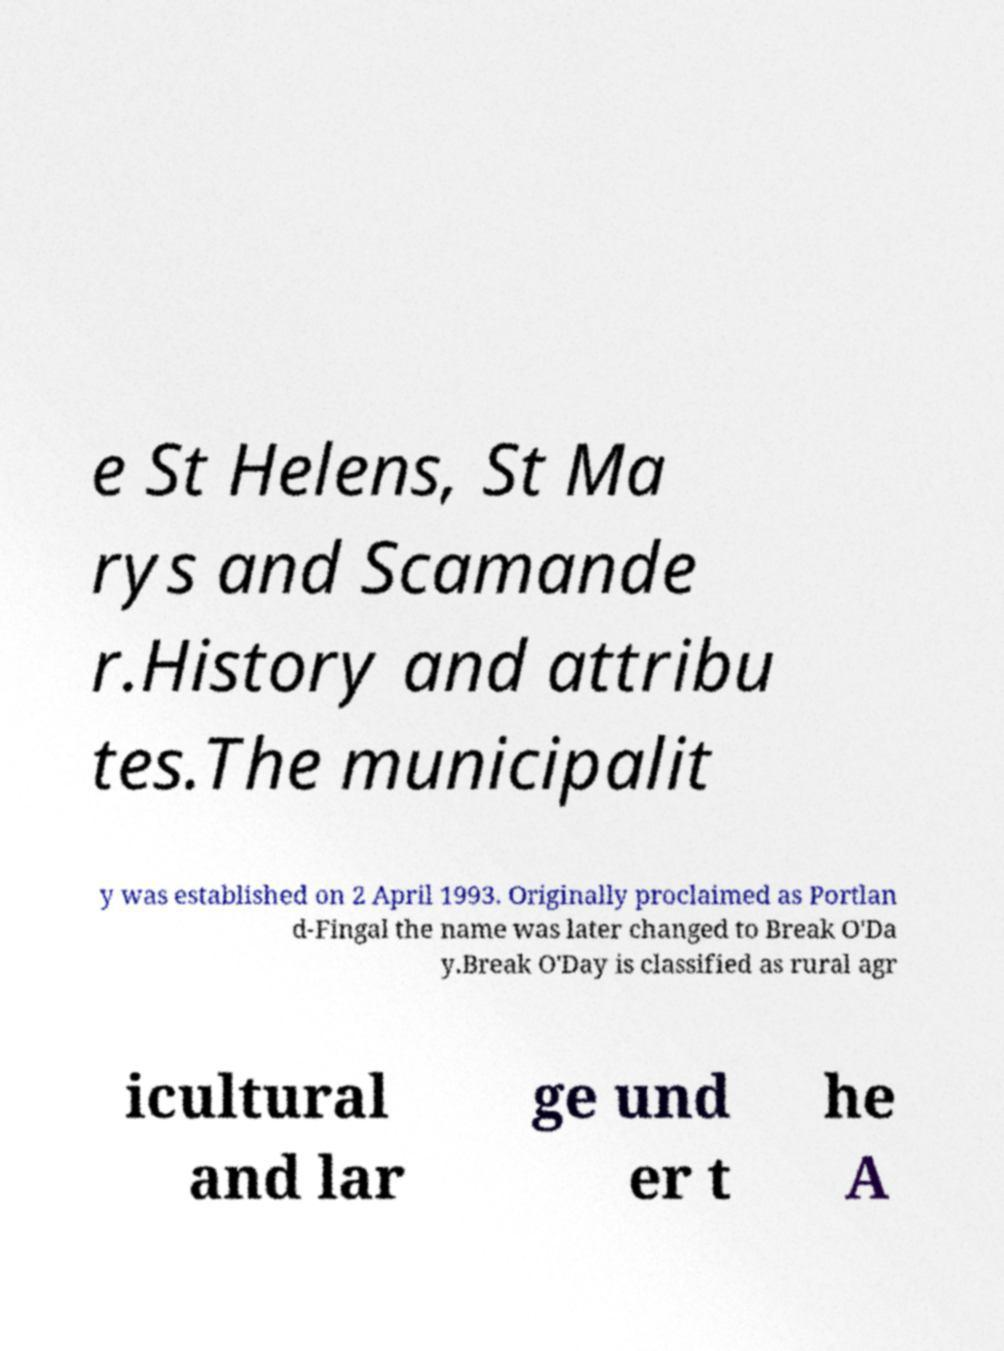For documentation purposes, I need the text within this image transcribed. Could you provide that? e St Helens, St Ma rys and Scamande r.History and attribu tes.The municipalit y was established on 2 April 1993. Originally proclaimed as Portlan d-Fingal the name was later changed to Break O'Da y.Break O'Day is classified as rural agr icultural and lar ge und er t he A 